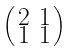<formula> <loc_0><loc_0><loc_500><loc_500>\begin{psmallmatrix} 2 & 1 \\ 1 & 1 \end{psmallmatrix}</formula> 